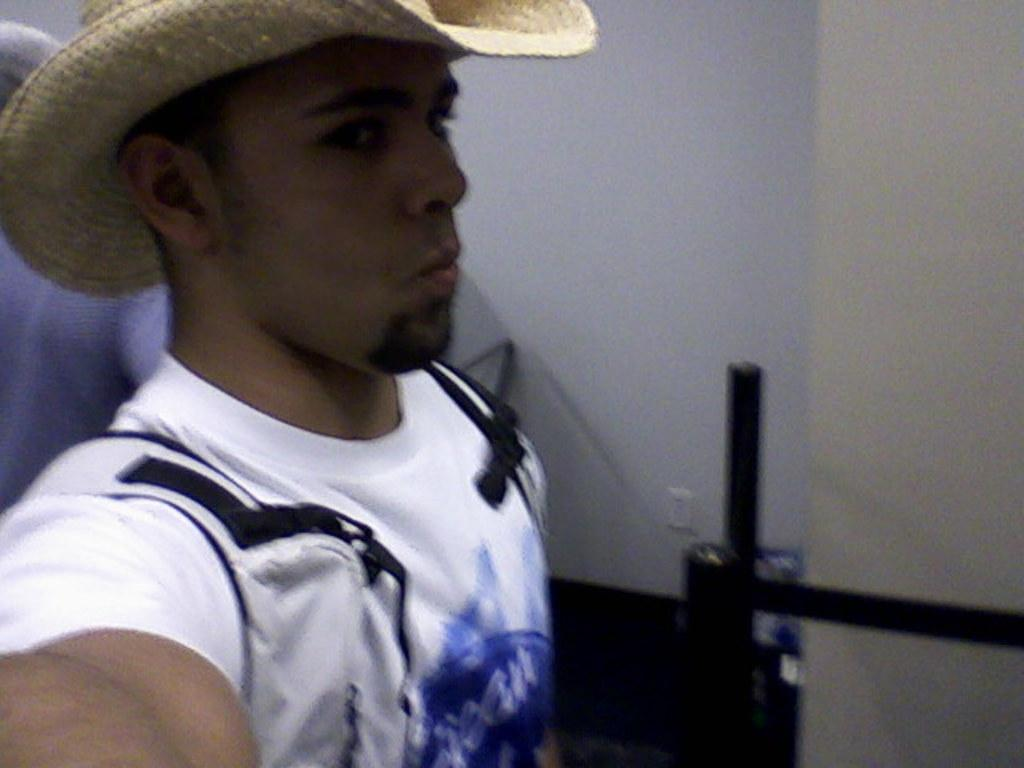Where was the image taken? The image is taken indoors. What can be seen in the background of the image? There is a wall in the background of the image. Who is present in the image? There is a man on the left side of the image. What is the man wearing on his head? The man is wearing a hat. What type of jeans is the man wearing in the image? There is no information about the man's jeans in the image, so we cannot determine the type of jeans he is wearing. 